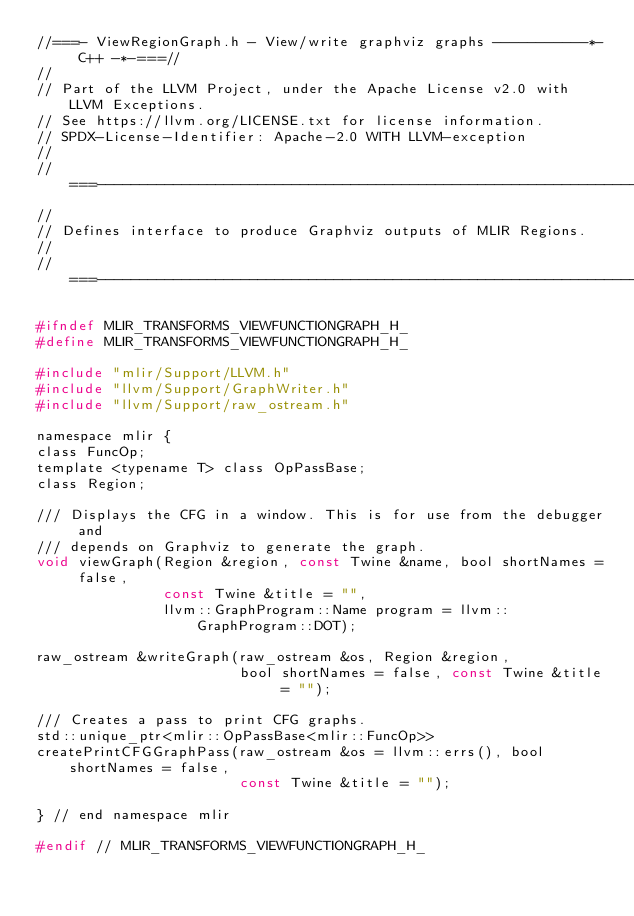<code> <loc_0><loc_0><loc_500><loc_500><_C_>//===- ViewRegionGraph.h - View/write graphviz graphs -----------*- C++ -*-===//
//
// Part of the LLVM Project, under the Apache License v2.0 with LLVM Exceptions.
// See https://llvm.org/LICENSE.txt for license information.
// SPDX-License-Identifier: Apache-2.0 WITH LLVM-exception
//
//===----------------------------------------------------------------------===//
//
// Defines interface to produce Graphviz outputs of MLIR Regions.
//
//===----------------------------------------------------------------------===//

#ifndef MLIR_TRANSFORMS_VIEWFUNCTIONGRAPH_H_
#define MLIR_TRANSFORMS_VIEWFUNCTIONGRAPH_H_

#include "mlir/Support/LLVM.h"
#include "llvm/Support/GraphWriter.h"
#include "llvm/Support/raw_ostream.h"

namespace mlir {
class FuncOp;
template <typename T> class OpPassBase;
class Region;

/// Displays the CFG in a window. This is for use from the debugger and
/// depends on Graphviz to generate the graph.
void viewGraph(Region &region, const Twine &name, bool shortNames = false,
               const Twine &title = "",
               llvm::GraphProgram::Name program = llvm::GraphProgram::DOT);

raw_ostream &writeGraph(raw_ostream &os, Region &region,
                        bool shortNames = false, const Twine &title = "");

/// Creates a pass to print CFG graphs.
std::unique_ptr<mlir::OpPassBase<mlir::FuncOp>>
createPrintCFGGraphPass(raw_ostream &os = llvm::errs(), bool shortNames = false,
                        const Twine &title = "");

} // end namespace mlir

#endif // MLIR_TRANSFORMS_VIEWFUNCTIONGRAPH_H_
</code> 